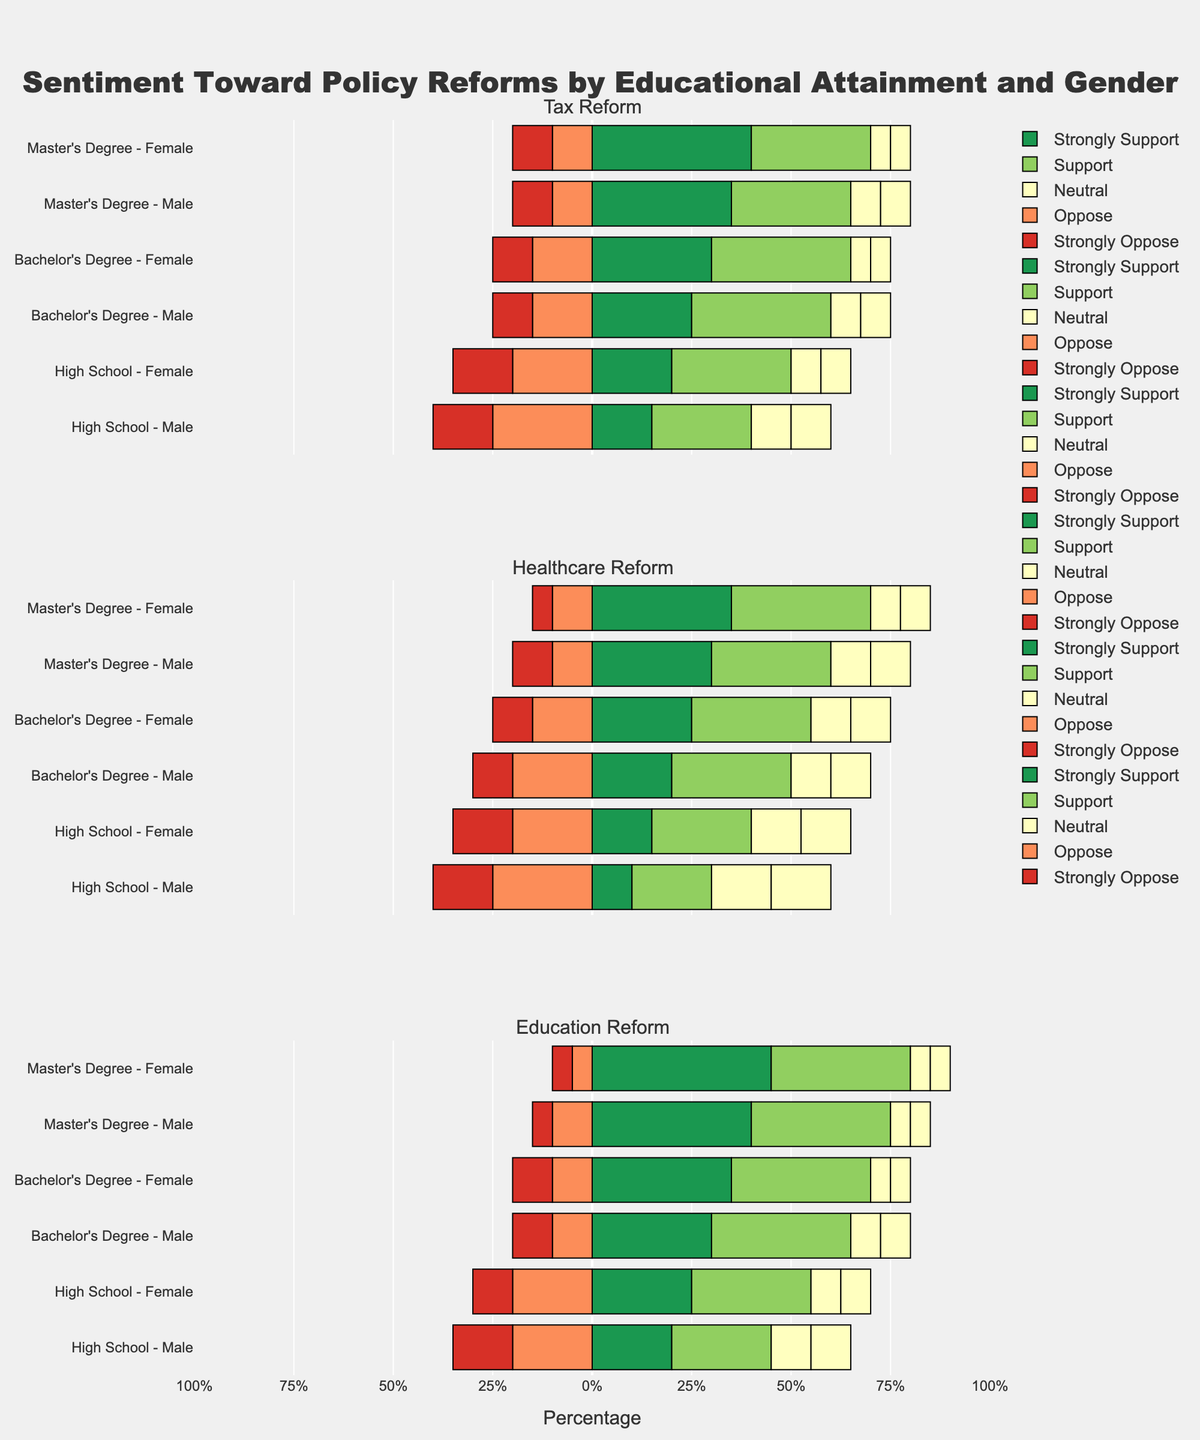Which gender with a Bachelor's Degree shows more support for Healthcare Reform? We compare the percentages of 'Support' for males and females with a Bachelor's Degree in the Healthcare Reform category. Males show 30% support while females show 30% support.
Answer: They show equal support What is the difference in the percentage of 'Strongly Oppose' for Education Reform between males and females with a Master's Degree? For Education Reform, the percentage of 'Strongly Oppose' is 5% for both males and females with a Master's Degree. The difference is therefore 0%.
Answer: 0% Which educational attainment group has the highest 'Strongly Support' for Tax Reform among females? Examining the 'Strongly Support' bars for females across different educational attainments in the Tax Reform category, females with a Master's Degree have the highest value at 40%.
Answer: Females with a Master's Degree Compare the total percentage of support ('Strongly Support' + 'Support') for high school males across all three policy reforms. For each policy reform:
Tax Reform: 15% + 25% = 40%
Healthcare Reform: 10% + 20% = 30%
Education Reform: 20% + 25% = 45%
Comparing these values, Education Reform shows the highest support.
Answer: Education Reform Which policy reform has the highest 'Oppose' percentage among males with a Bachelor's Degree? Check the 'Oppose' values for males with a Bachelor's Degree across all categories:
Tax Reform: 15%
Healthcare Reform: 20%
Education Reform: 10%
The highest 'Oppose' value is for Healthcare Reform at 20%.
Answer: Healthcare Reform What is the combined percentage of 'Neutral' responses for females with Master's Degrees across all reforms? Summing up the 'Neutral' percentages for females with a Master's Degree:
Tax Reform: 10%
Healthcare Reform: 15%
Education Reform: 10%
Combined percentage: 10% + 15% + 10% = 35%
Answer: 35% Compare the 'Strongly Support' percentages for males with Bachelor's Degrees between Tax Reform and Education Reform. Which one is higher? For males with a Bachelor's Degree:
Tax Reform: 25%
Education Reform: 30%
Education Reform has a higher 'Strongly Support' percentage at 30%.
Answer: Education Reform Which policy reform shows equal 'Strongly Oppose' percentages for males and females with High School education? Observing the 'Strongly Oppose' values for males and females with High School education across all categories:
Tax Reform: males 15%, females 15%
Healthcare Reform: males 15%, females 15%
Education Reform: males 15%, females 10%
Only Tax Reform and Healthcare Reform show equal 'Strongly Oppose' percentages of 15%.
Answer: Tax Reform, Healthcare Reform What is the percentage difference in 'Oppose' sentiment between males and females with High School education in Healthcare Reform? For Healthcare Reform, the 'Oppose' value for High School males is 25%, and for High School females, it is 20%. The difference is 25% - 20% = 5%.
Answer: 5% Which gender with a Master's Degree has a higher combined percentage for Healthcare Reform's support ('Strongly Support' + 'Support')? Males with a Master's:
30% + 30% = 60%
Females with a Master's:
35% + 35% = 70%
Females with a Master's Degree have a higher combined support percentage.
Answer: Females 